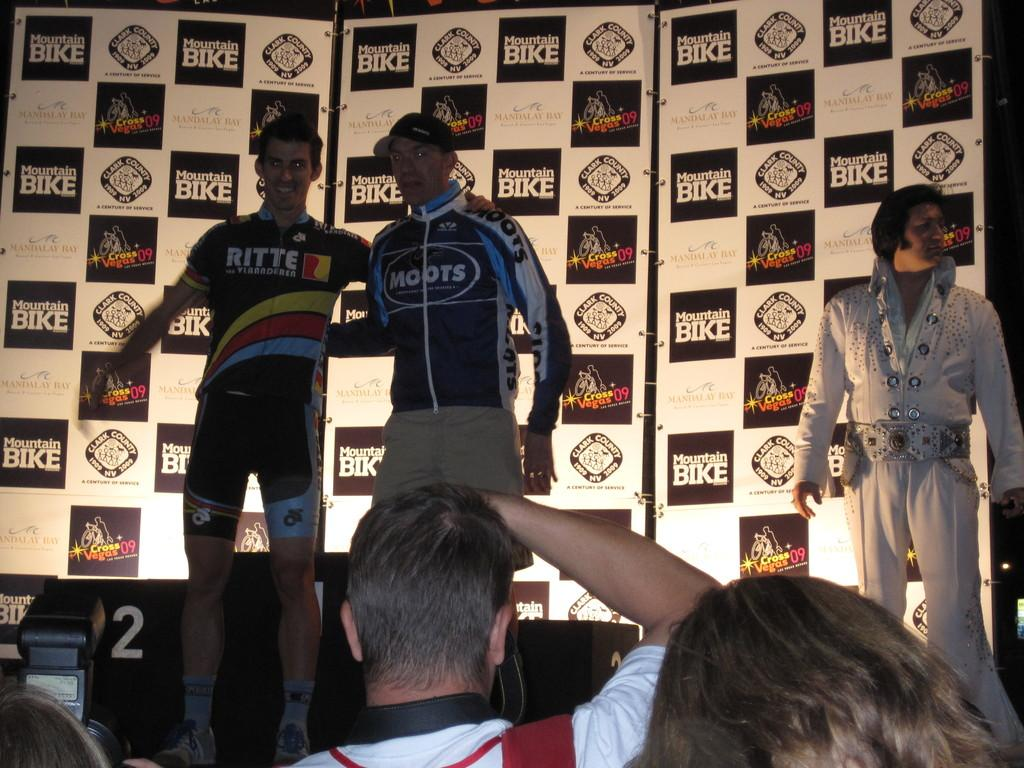<image>
Create a compact narrative representing the image presented. a few people with a mountain bike ad behind them 